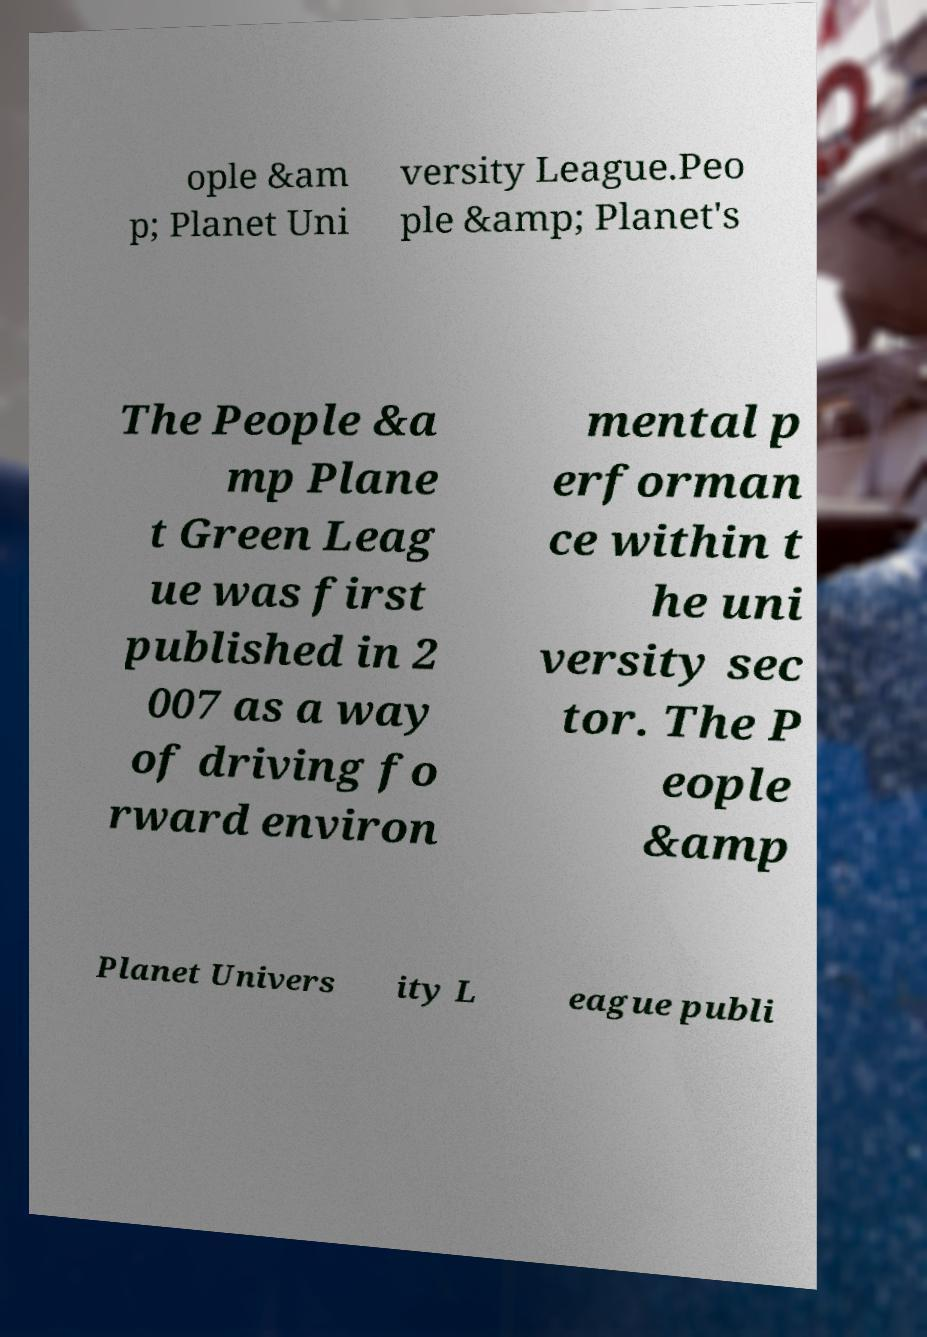Please read and relay the text visible in this image. What does it say? ople &am p; Planet Uni versity League.Peo ple &amp; Planet's The People &a mp Plane t Green Leag ue was first published in 2 007 as a way of driving fo rward environ mental p erforman ce within t he uni versity sec tor. The P eople &amp Planet Univers ity L eague publi 